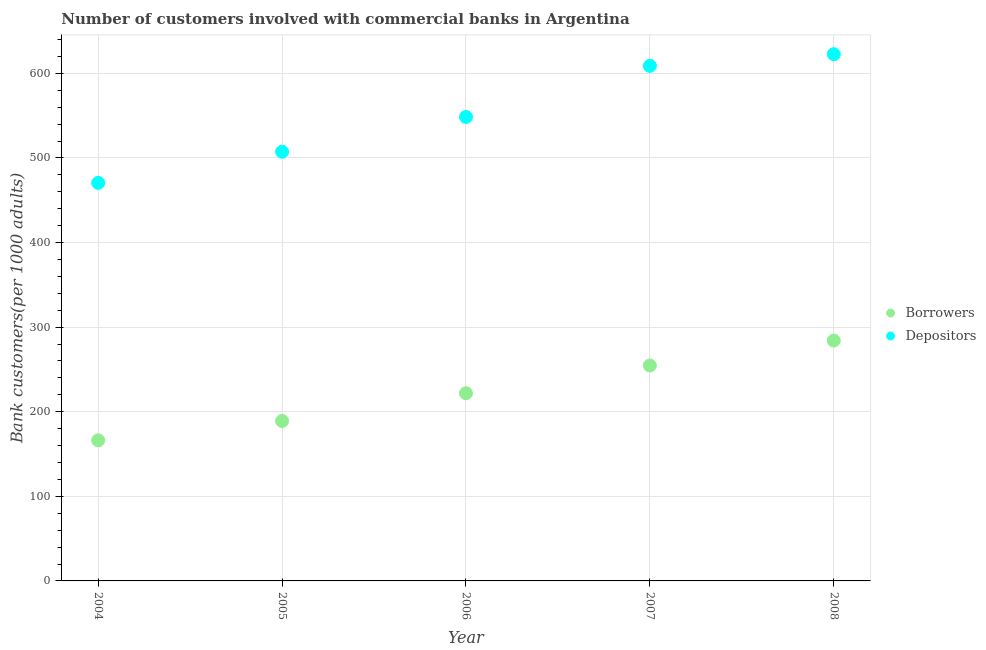Is the number of dotlines equal to the number of legend labels?
Offer a very short reply. Yes. What is the number of depositors in 2004?
Your response must be concise. 470.57. Across all years, what is the maximum number of borrowers?
Provide a short and direct response. 284.14. Across all years, what is the minimum number of borrowers?
Your answer should be compact. 166.23. What is the total number of borrowers in the graph?
Your response must be concise. 1116.06. What is the difference between the number of depositors in 2006 and that in 2008?
Your answer should be very brief. -74.2. What is the difference between the number of borrowers in 2006 and the number of depositors in 2005?
Keep it short and to the point. -285.52. What is the average number of borrowers per year?
Your response must be concise. 223.21. In the year 2006, what is the difference between the number of depositors and number of borrowers?
Your response must be concise. 326.62. What is the ratio of the number of depositors in 2006 to that in 2008?
Your answer should be compact. 0.88. Is the difference between the number of depositors in 2005 and 2007 greater than the difference between the number of borrowers in 2005 and 2007?
Offer a very short reply. No. What is the difference between the highest and the second highest number of borrowers?
Keep it short and to the point. 29.45. What is the difference between the highest and the lowest number of depositors?
Keep it short and to the point. 152.16. In how many years, is the number of depositors greater than the average number of depositors taken over all years?
Your response must be concise. 2. Is the sum of the number of depositors in 2007 and 2008 greater than the maximum number of borrowers across all years?
Offer a terse response. Yes. Is the number of depositors strictly greater than the number of borrowers over the years?
Your response must be concise. Yes. How many years are there in the graph?
Make the answer very short. 5. What is the difference between two consecutive major ticks on the Y-axis?
Your answer should be compact. 100. Does the graph contain any zero values?
Your answer should be very brief. No. Where does the legend appear in the graph?
Ensure brevity in your answer.  Center right. How many legend labels are there?
Your answer should be compact. 2. What is the title of the graph?
Ensure brevity in your answer.  Number of customers involved with commercial banks in Argentina. What is the label or title of the X-axis?
Give a very brief answer. Year. What is the label or title of the Y-axis?
Your response must be concise. Bank customers(per 1000 adults). What is the Bank customers(per 1000 adults) in Borrowers in 2004?
Provide a short and direct response. 166.23. What is the Bank customers(per 1000 adults) of Depositors in 2004?
Your answer should be compact. 470.57. What is the Bank customers(per 1000 adults) of Borrowers in 2005?
Keep it short and to the point. 189.09. What is the Bank customers(per 1000 adults) of Depositors in 2005?
Offer a terse response. 507.43. What is the Bank customers(per 1000 adults) of Borrowers in 2006?
Your response must be concise. 221.91. What is the Bank customers(per 1000 adults) of Depositors in 2006?
Offer a very short reply. 548.53. What is the Bank customers(per 1000 adults) of Borrowers in 2007?
Offer a terse response. 254.69. What is the Bank customers(per 1000 adults) in Depositors in 2007?
Provide a succinct answer. 608.93. What is the Bank customers(per 1000 adults) of Borrowers in 2008?
Give a very brief answer. 284.14. What is the Bank customers(per 1000 adults) in Depositors in 2008?
Offer a terse response. 622.73. Across all years, what is the maximum Bank customers(per 1000 adults) of Borrowers?
Your answer should be compact. 284.14. Across all years, what is the maximum Bank customers(per 1000 adults) of Depositors?
Give a very brief answer. 622.73. Across all years, what is the minimum Bank customers(per 1000 adults) of Borrowers?
Ensure brevity in your answer.  166.23. Across all years, what is the minimum Bank customers(per 1000 adults) in Depositors?
Your answer should be very brief. 470.57. What is the total Bank customers(per 1000 adults) in Borrowers in the graph?
Your answer should be very brief. 1116.06. What is the total Bank customers(per 1000 adults) of Depositors in the graph?
Provide a short and direct response. 2758.19. What is the difference between the Bank customers(per 1000 adults) of Borrowers in 2004 and that in 2005?
Provide a short and direct response. -22.86. What is the difference between the Bank customers(per 1000 adults) in Depositors in 2004 and that in 2005?
Offer a terse response. -36.86. What is the difference between the Bank customers(per 1000 adults) of Borrowers in 2004 and that in 2006?
Make the answer very short. -55.69. What is the difference between the Bank customers(per 1000 adults) of Depositors in 2004 and that in 2006?
Ensure brevity in your answer.  -77.96. What is the difference between the Bank customers(per 1000 adults) of Borrowers in 2004 and that in 2007?
Offer a terse response. -88.46. What is the difference between the Bank customers(per 1000 adults) of Depositors in 2004 and that in 2007?
Provide a short and direct response. -138.35. What is the difference between the Bank customers(per 1000 adults) in Borrowers in 2004 and that in 2008?
Your answer should be compact. -117.91. What is the difference between the Bank customers(per 1000 adults) in Depositors in 2004 and that in 2008?
Your response must be concise. -152.16. What is the difference between the Bank customers(per 1000 adults) in Borrowers in 2005 and that in 2006?
Offer a very short reply. -32.82. What is the difference between the Bank customers(per 1000 adults) in Depositors in 2005 and that in 2006?
Provide a succinct answer. -41.1. What is the difference between the Bank customers(per 1000 adults) in Borrowers in 2005 and that in 2007?
Provide a short and direct response. -65.6. What is the difference between the Bank customers(per 1000 adults) of Depositors in 2005 and that in 2007?
Keep it short and to the point. -101.5. What is the difference between the Bank customers(per 1000 adults) of Borrowers in 2005 and that in 2008?
Give a very brief answer. -95.05. What is the difference between the Bank customers(per 1000 adults) of Depositors in 2005 and that in 2008?
Your answer should be compact. -115.3. What is the difference between the Bank customers(per 1000 adults) of Borrowers in 2006 and that in 2007?
Offer a terse response. -32.78. What is the difference between the Bank customers(per 1000 adults) of Depositors in 2006 and that in 2007?
Your answer should be very brief. -60.4. What is the difference between the Bank customers(per 1000 adults) of Borrowers in 2006 and that in 2008?
Keep it short and to the point. -62.22. What is the difference between the Bank customers(per 1000 adults) in Depositors in 2006 and that in 2008?
Give a very brief answer. -74.2. What is the difference between the Bank customers(per 1000 adults) of Borrowers in 2007 and that in 2008?
Your answer should be compact. -29.45. What is the difference between the Bank customers(per 1000 adults) of Depositors in 2007 and that in 2008?
Give a very brief answer. -13.81. What is the difference between the Bank customers(per 1000 adults) of Borrowers in 2004 and the Bank customers(per 1000 adults) of Depositors in 2005?
Offer a terse response. -341.2. What is the difference between the Bank customers(per 1000 adults) of Borrowers in 2004 and the Bank customers(per 1000 adults) of Depositors in 2006?
Provide a succinct answer. -382.3. What is the difference between the Bank customers(per 1000 adults) in Borrowers in 2004 and the Bank customers(per 1000 adults) in Depositors in 2007?
Provide a short and direct response. -442.7. What is the difference between the Bank customers(per 1000 adults) in Borrowers in 2004 and the Bank customers(per 1000 adults) in Depositors in 2008?
Your answer should be compact. -456.51. What is the difference between the Bank customers(per 1000 adults) in Borrowers in 2005 and the Bank customers(per 1000 adults) in Depositors in 2006?
Keep it short and to the point. -359.44. What is the difference between the Bank customers(per 1000 adults) of Borrowers in 2005 and the Bank customers(per 1000 adults) of Depositors in 2007?
Ensure brevity in your answer.  -419.83. What is the difference between the Bank customers(per 1000 adults) in Borrowers in 2005 and the Bank customers(per 1000 adults) in Depositors in 2008?
Provide a short and direct response. -433.64. What is the difference between the Bank customers(per 1000 adults) in Borrowers in 2006 and the Bank customers(per 1000 adults) in Depositors in 2007?
Your answer should be very brief. -387.01. What is the difference between the Bank customers(per 1000 adults) of Borrowers in 2006 and the Bank customers(per 1000 adults) of Depositors in 2008?
Ensure brevity in your answer.  -400.82. What is the difference between the Bank customers(per 1000 adults) in Borrowers in 2007 and the Bank customers(per 1000 adults) in Depositors in 2008?
Your response must be concise. -368.04. What is the average Bank customers(per 1000 adults) in Borrowers per year?
Keep it short and to the point. 223.21. What is the average Bank customers(per 1000 adults) in Depositors per year?
Ensure brevity in your answer.  551.64. In the year 2004, what is the difference between the Bank customers(per 1000 adults) of Borrowers and Bank customers(per 1000 adults) of Depositors?
Give a very brief answer. -304.35. In the year 2005, what is the difference between the Bank customers(per 1000 adults) of Borrowers and Bank customers(per 1000 adults) of Depositors?
Your answer should be compact. -318.34. In the year 2006, what is the difference between the Bank customers(per 1000 adults) of Borrowers and Bank customers(per 1000 adults) of Depositors?
Make the answer very short. -326.62. In the year 2007, what is the difference between the Bank customers(per 1000 adults) of Borrowers and Bank customers(per 1000 adults) of Depositors?
Make the answer very short. -354.23. In the year 2008, what is the difference between the Bank customers(per 1000 adults) in Borrowers and Bank customers(per 1000 adults) in Depositors?
Your answer should be compact. -338.6. What is the ratio of the Bank customers(per 1000 adults) in Borrowers in 2004 to that in 2005?
Your answer should be compact. 0.88. What is the ratio of the Bank customers(per 1000 adults) of Depositors in 2004 to that in 2005?
Ensure brevity in your answer.  0.93. What is the ratio of the Bank customers(per 1000 adults) in Borrowers in 2004 to that in 2006?
Ensure brevity in your answer.  0.75. What is the ratio of the Bank customers(per 1000 adults) in Depositors in 2004 to that in 2006?
Offer a terse response. 0.86. What is the ratio of the Bank customers(per 1000 adults) of Borrowers in 2004 to that in 2007?
Your answer should be very brief. 0.65. What is the ratio of the Bank customers(per 1000 adults) in Depositors in 2004 to that in 2007?
Your answer should be very brief. 0.77. What is the ratio of the Bank customers(per 1000 adults) of Borrowers in 2004 to that in 2008?
Your response must be concise. 0.58. What is the ratio of the Bank customers(per 1000 adults) of Depositors in 2004 to that in 2008?
Your response must be concise. 0.76. What is the ratio of the Bank customers(per 1000 adults) of Borrowers in 2005 to that in 2006?
Your answer should be very brief. 0.85. What is the ratio of the Bank customers(per 1000 adults) in Depositors in 2005 to that in 2006?
Offer a very short reply. 0.93. What is the ratio of the Bank customers(per 1000 adults) of Borrowers in 2005 to that in 2007?
Offer a very short reply. 0.74. What is the ratio of the Bank customers(per 1000 adults) in Depositors in 2005 to that in 2007?
Offer a very short reply. 0.83. What is the ratio of the Bank customers(per 1000 adults) in Borrowers in 2005 to that in 2008?
Your answer should be very brief. 0.67. What is the ratio of the Bank customers(per 1000 adults) in Depositors in 2005 to that in 2008?
Your answer should be very brief. 0.81. What is the ratio of the Bank customers(per 1000 adults) of Borrowers in 2006 to that in 2007?
Ensure brevity in your answer.  0.87. What is the ratio of the Bank customers(per 1000 adults) in Depositors in 2006 to that in 2007?
Ensure brevity in your answer.  0.9. What is the ratio of the Bank customers(per 1000 adults) in Borrowers in 2006 to that in 2008?
Give a very brief answer. 0.78. What is the ratio of the Bank customers(per 1000 adults) of Depositors in 2006 to that in 2008?
Your answer should be very brief. 0.88. What is the ratio of the Bank customers(per 1000 adults) in Borrowers in 2007 to that in 2008?
Provide a succinct answer. 0.9. What is the ratio of the Bank customers(per 1000 adults) of Depositors in 2007 to that in 2008?
Give a very brief answer. 0.98. What is the difference between the highest and the second highest Bank customers(per 1000 adults) in Borrowers?
Your response must be concise. 29.45. What is the difference between the highest and the second highest Bank customers(per 1000 adults) of Depositors?
Your response must be concise. 13.81. What is the difference between the highest and the lowest Bank customers(per 1000 adults) of Borrowers?
Provide a succinct answer. 117.91. What is the difference between the highest and the lowest Bank customers(per 1000 adults) in Depositors?
Make the answer very short. 152.16. 